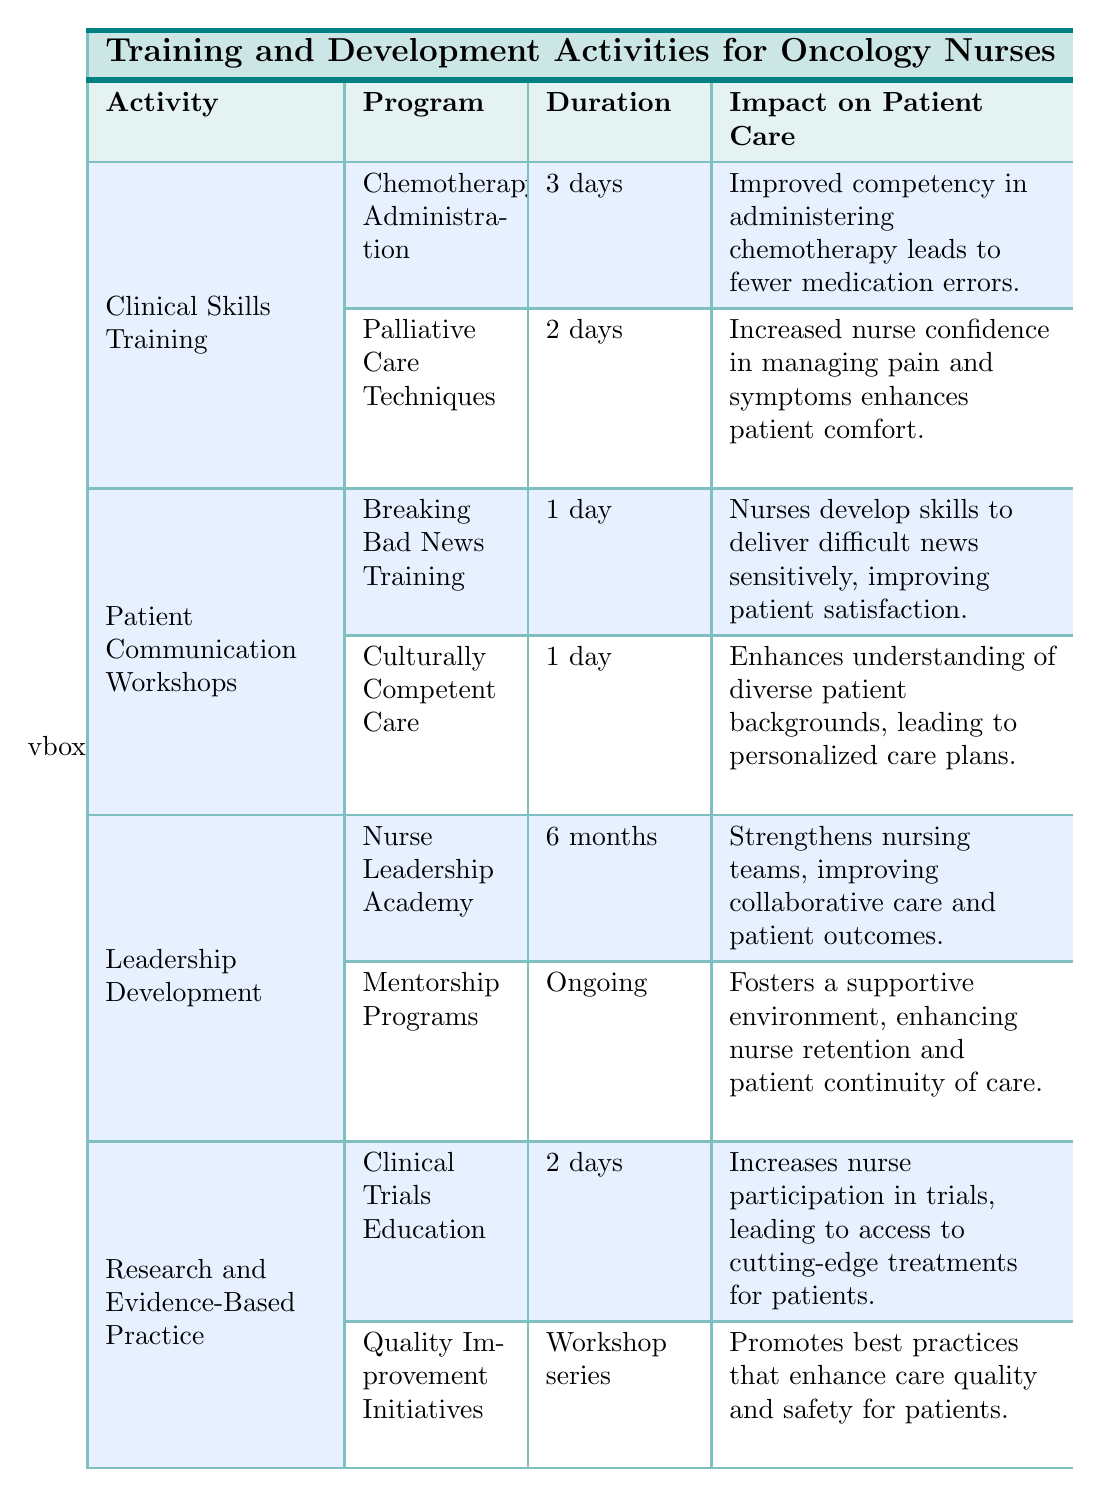What is the duration of the Chemotherapy Administration training? The table provides specific information about each training program, and for the Chemotherapy Administration program, it states that the duration is 3 days.
Answer: 3 days What are the two main impacts on patient care of the Palliative Care Techniques training? The table indicates that the Palliative Care Techniques training leads to two main impacts: increased nurse confidence in managing pain and symptoms, and enhances patient comfort.
Answer: Increased nurse confidence; enhances patient comfort Is there any training that focuses on culturally competent care? By examining the table, we can see that there is a program titled "Culturally Competent Care" that is part of the Patient Communication Workshops category, confirming that there is a training focused on this area.
Answer: Yes What is the total duration of the Nurse Leadership Academy program? The Nurse Leadership Academy program has a specified duration of 6 months according to the table, which directly answers the question about its total duration.
Answer: 6 months How many training programs directly improve nurse competency in clinical skills? The table shows there are two clinical skills training programs: Chemotherapy Administration and Palliative Care Techniques. Therefore, the total number of programs that directly improve clinical skills is two.
Answer: 2 What is the impact on patient care from attending the Clinical Trials Education program? According to the table, the Clinical Trials Education program leads to an increase in nurse participation in trials, which allows patients access to cutting-edge treatments. This is the specific impact mentioned in the table.
Answer: Access to cutting-edge treatments Is the Mentorship Programs training ongoing? The duration of the Mentorship Programs is specified as "Ongoing" in the table, which clearly indicates that this particular training is indeed ongoing.
Answer: Yes Which training program has the longest duration, and what is it? By comparing the durations listed for each program, the Nurse Leadership Academy program has the longest duration at 6 months, making it the longest training program in the table.
Answer: Nurse Leadership Academy; 6 months What can be inferred about the focus of Patient Communication Workshops based on the provided impacts? The impacts listed for the Patient Communication Workshops, such as delivering difficult news sensitively and enhancing understanding of diverse backgrounds, suggest a strong emphasis on improving communication skills and patient satisfaction throughout these workshops.
Answer: Improved communication skills and patient satisfaction 